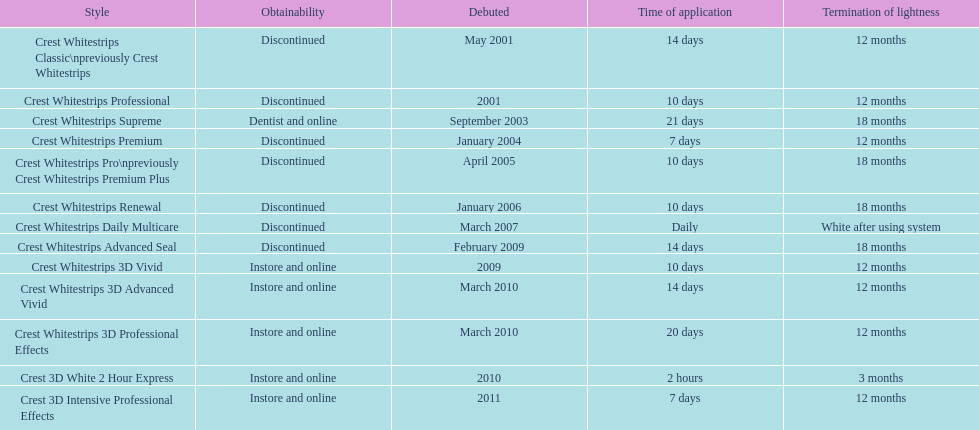What product was introduced in the same month as crest whitestrips 3d advanced vivid? Crest Whitestrips 3D Professional Effects. 